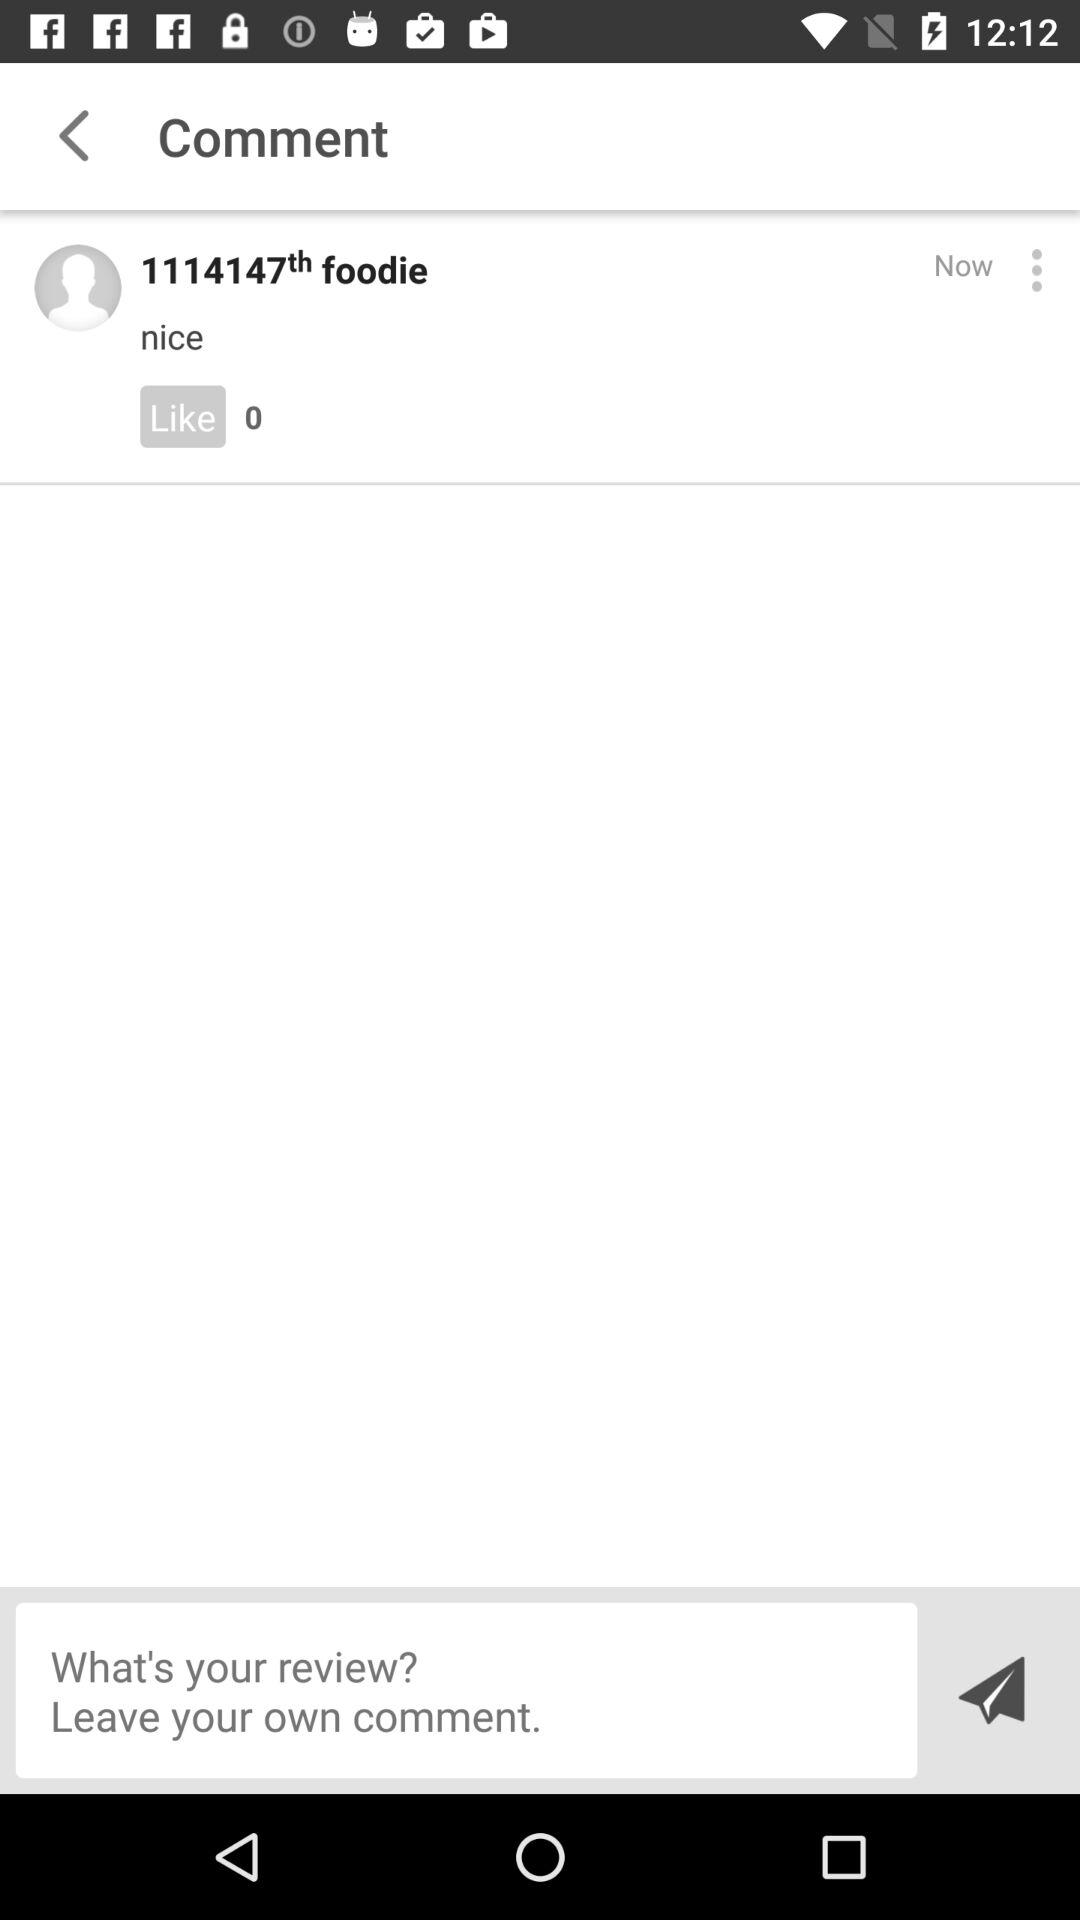How many likes are there on the comment? There are 0 likes. 